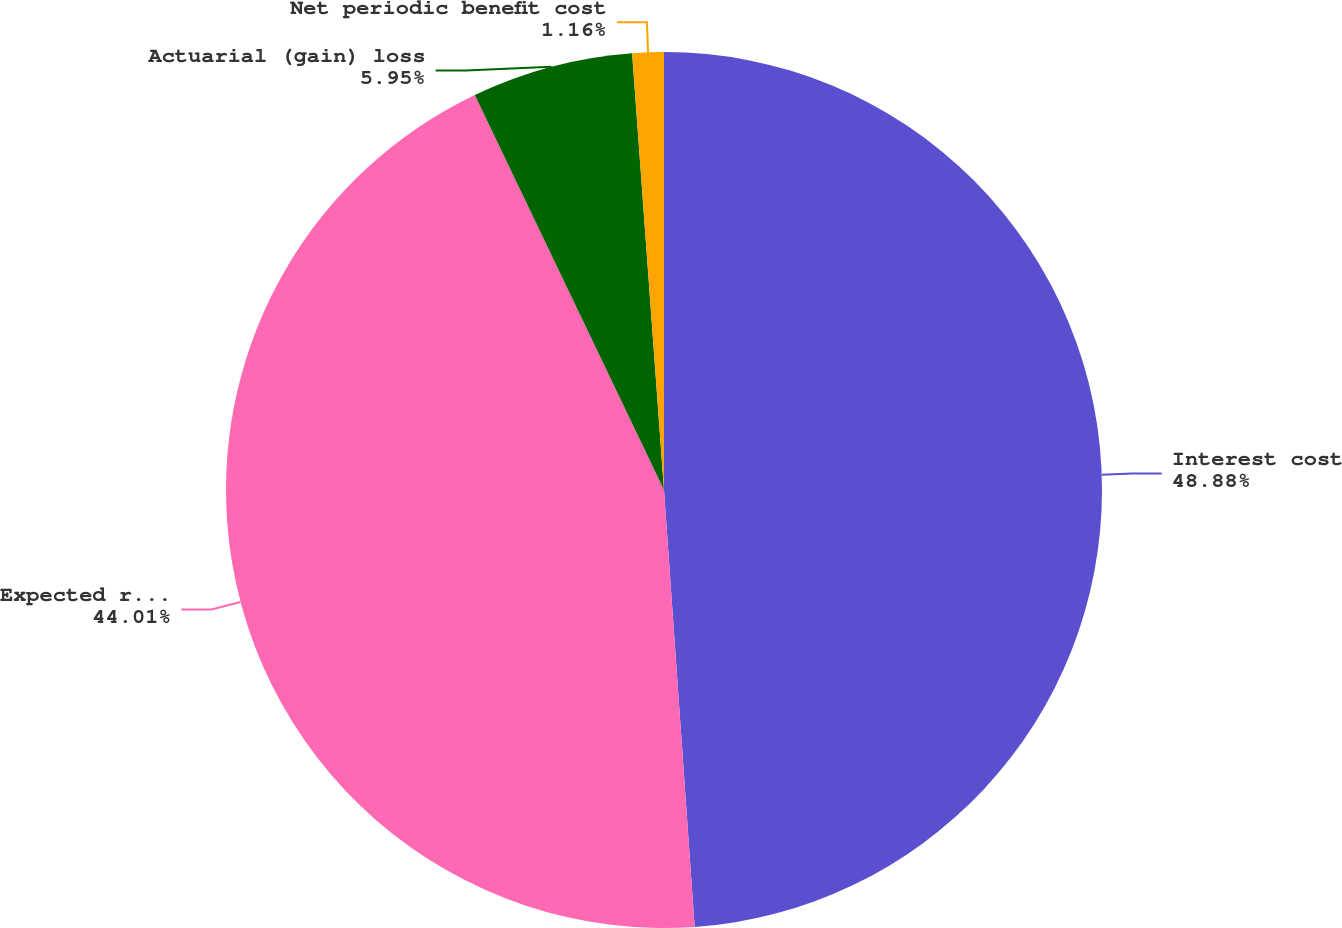Convert chart to OTSL. <chart><loc_0><loc_0><loc_500><loc_500><pie_chart><fcel>Interest cost<fcel>Expected return on plan assets<fcel>Actuarial (gain) loss<fcel>Net periodic benefit cost<nl><fcel>48.89%<fcel>44.01%<fcel>5.95%<fcel>1.16%<nl></chart> 